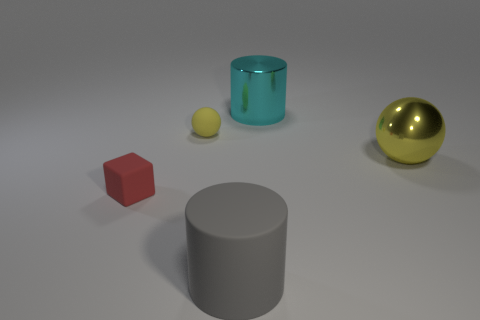Add 1 big metallic balls. How many objects exist? 6 Subtract 1 cylinders. How many cylinders are left? 1 Subtract all cubes. How many objects are left? 4 Subtract 0 brown cylinders. How many objects are left? 5 Subtract all brown cylinders. Subtract all cyan blocks. How many cylinders are left? 2 Subtract all green balls. How many gray cylinders are left? 1 Subtract all cyan matte objects. Subtract all gray things. How many objects are left? 4 Add 5 matte balls. How many matte balls are left? 6 Add 1 yellow metallic objects. How many yellow metallic objects exist? 2 